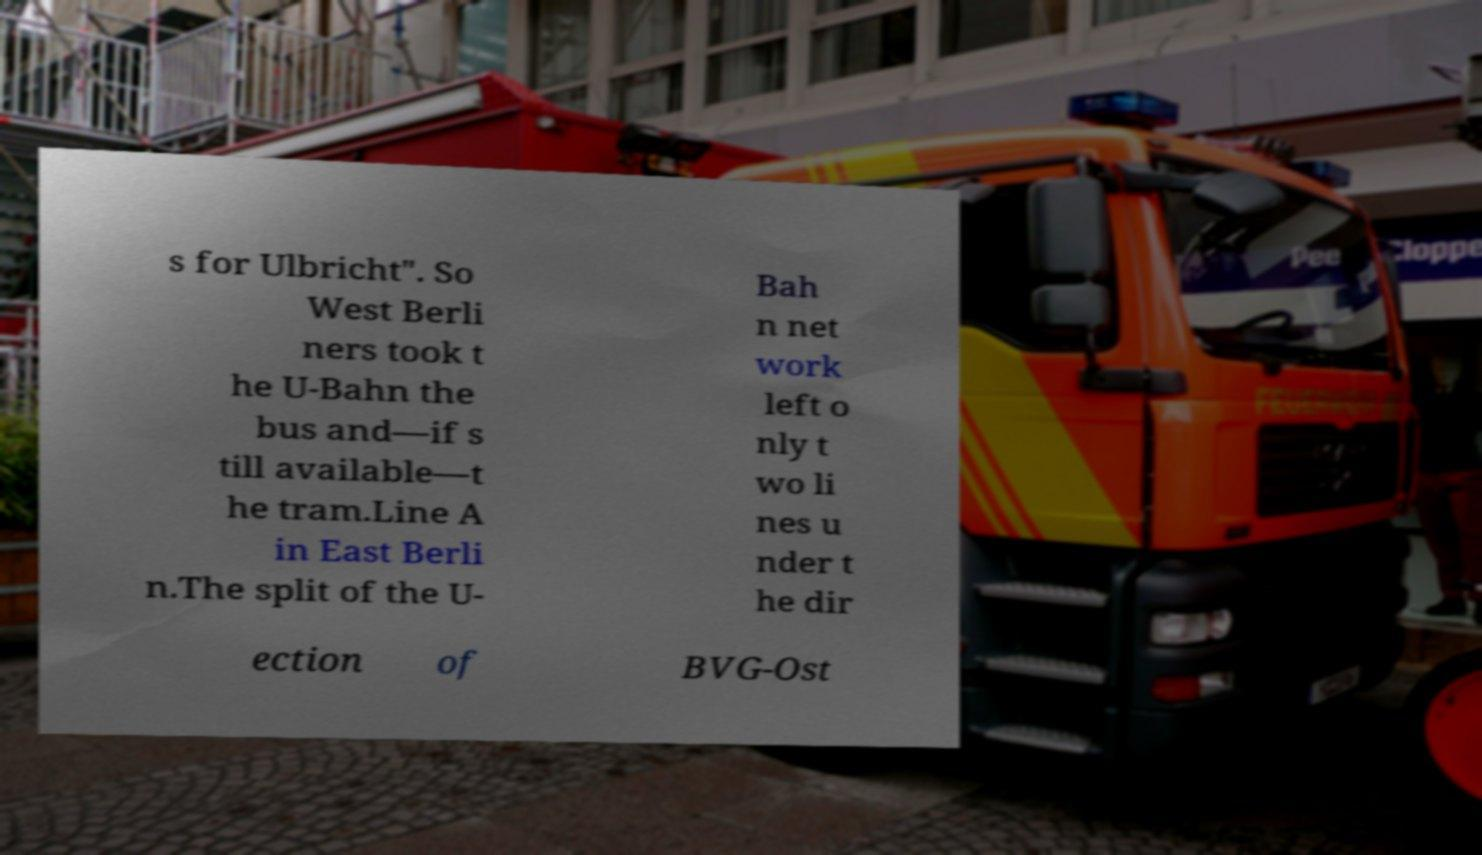Please identify and transcribe the text found in this image. s for Ulbricht". So West Berli ners took t he U-Bahn the bus and—if s till available—t he tram.Line A in East Berli n.The split of the U- Bah n net work left o nly t wo li nes u nder t he dir ection of BVG-Ost 